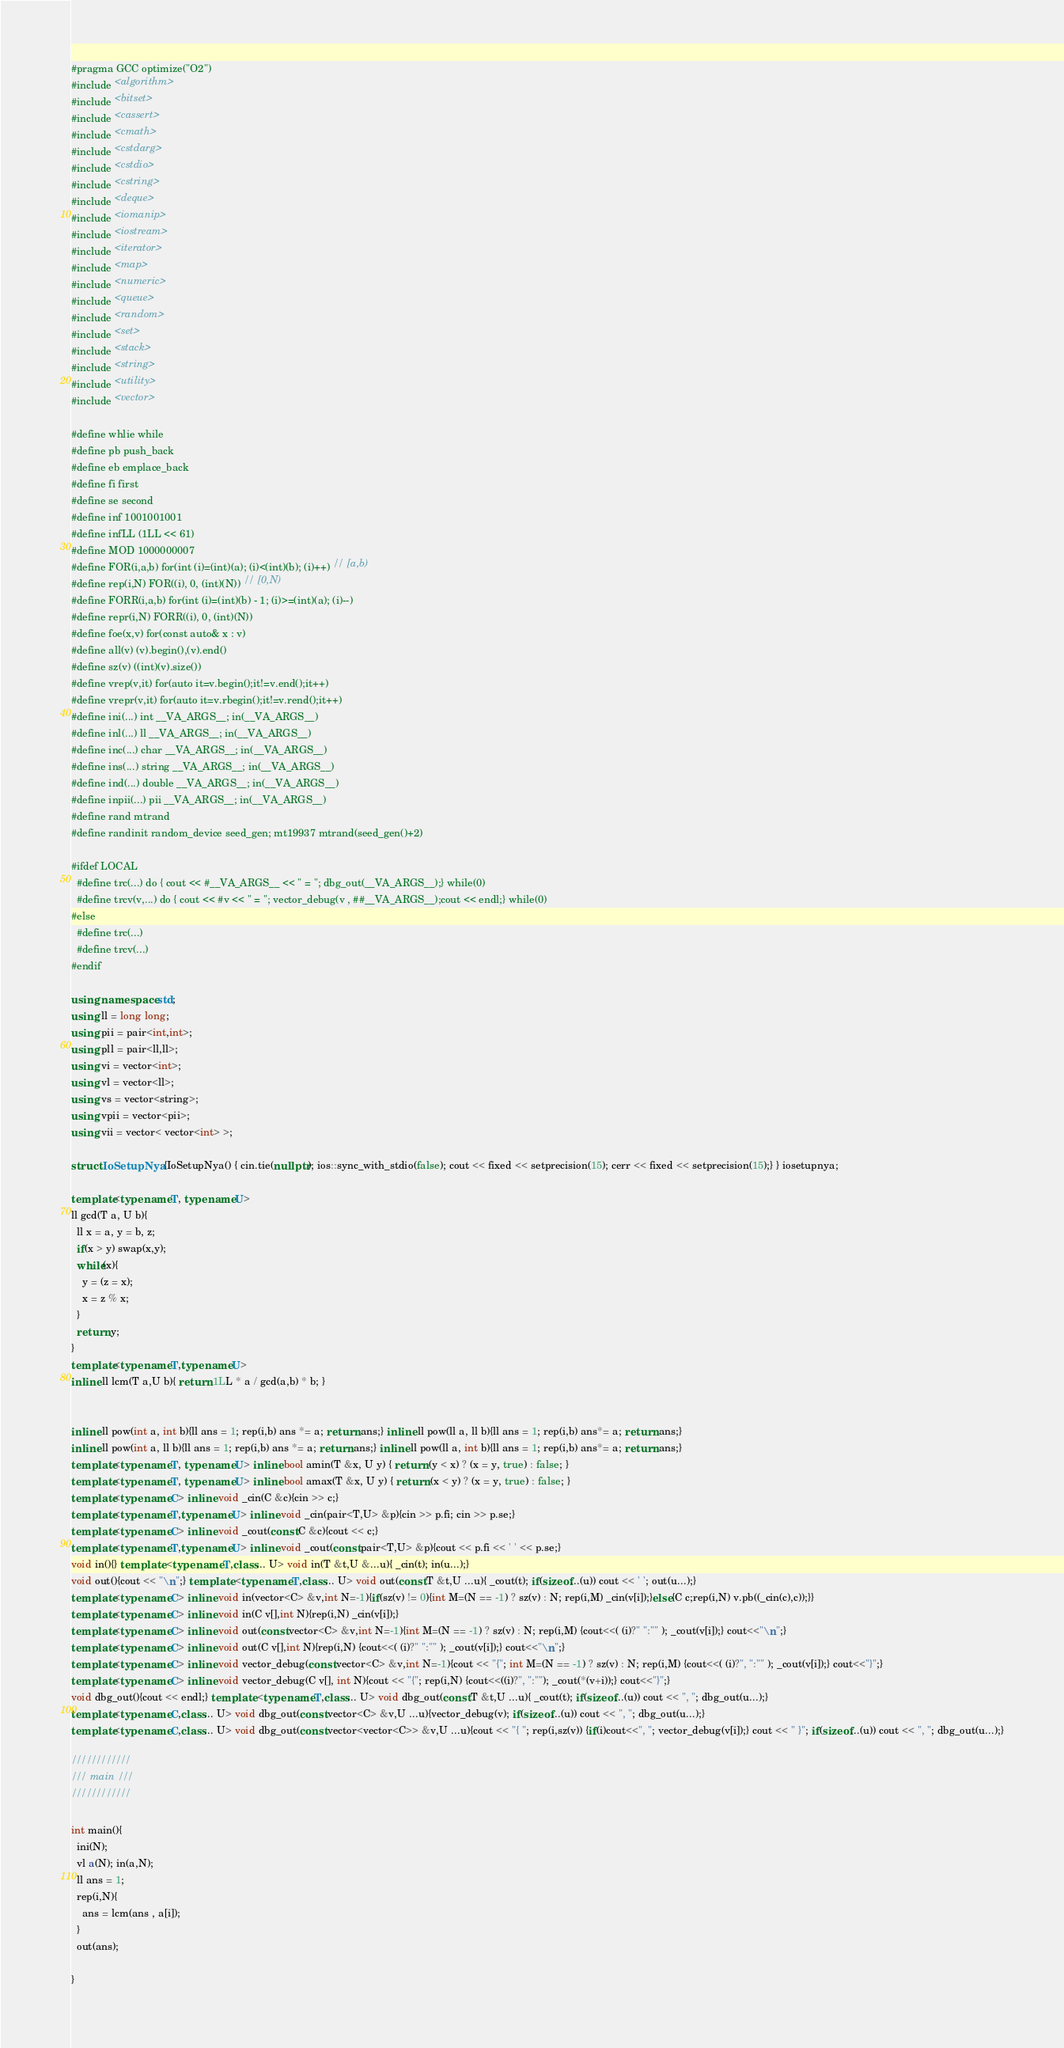<code> <loc_0><loc_0><loc_500><loc_500><_C++_>#pragma GCC optimize("O2")
#include <algorithm>
#include <bitset>
#include <cassert>
#include <cmath>
#include <cstdarg>
#include <cstdio>
#include <cstring>
#include <deque>
#include <iomanip>
#include <iostream>
#include <iterator>
#include <map>
#include <numeric>
#include <queue>
#include <random>
#include <set>
#include <stack>
#include <string>
#include <utility>
#include <vector>

#define whlie while
#define pb push_back
#define eb emplace_back
#define fi first
#define se second
#define inf 1001001001
#define infLL (1LL << 61)
#define MOD 1000000007
#define FOR(i,a,b) for(int (i)=(int)(a); (i)<(int)(b); (i)++) // [a,b)
#define rep(i,N) FOR((i), 0, (int)(N)) // [0,N)
#define FORR(i,a,b) for(int (i)=(int)(b) - 1; (i)>=(int)(a); (i)--)
#define repr(i,N) FORR((i), 0, (int)(N))
#define foe(x,v) for(const auto& x : v)
#define all(v) (v).begin(),(v).end()
#define sz(v) ((int)(v).size())
#define vrep(v,it) for(auto it=v.begin();it!=v.end();it++)
#define vrepr(v,it) for(auto it=v.rbegin();it!=v.rend();it++)
#define ini(...) int __VA_ARGS__; in(__VA_ARGS__)
#define inl(...) ll __VA_ARGS__; in(__VA_ARGS__)
#define inc(...) char __VA_ARGS__; in(__VA_ARGS__)
#define ins(...) string __VA_ARGS__; in(__VA_ARGS__)
#define ind(...) double __VA_ARGS__; in(__VA_ARGS__)
#define inpii(...) pii __VA_ARGS__; in(__VA_ARGS__)
#define rand mtrand
#define randinit random_device seed_gen; mt19937 mtrand(seed_gen()+2)

#ifdef LOCAL  
  #define trc(...) do { cout << #__VA_ARGS__ << " = "; dbg_out(__VA_ARGS__);} while(0)
  #define trcv(v,...) do { cout << #v << " = "; vector_debug(v , ##__VA_ARGS__);cout << endl;} while(0)
#else
  #define trc(...)
  #define trcv(...)
#endif

using namespace std;
using ll = long long;
using pii = pair<int,int>;
using pll = pair<ll,ll>;
using vi = vector<int>;
using vl = vector<ll>;
using vs = vector<string>;
using vpii = vector<pii>;
using vii = vector< vector<int> >;

struct IoSetupNya {IoSetupNya() { cin.tie(nullptr); ios::sync_with_stdio(false); cout << fixed << setprecision(15); cerr << fixed << setprecision(15);} } iosetupnya;

template<typename T, typename U>
ll gcd(T a, U b){
  ll x = a, y = b, z;
  if(x > y) swap(x,y);
  while(x){
    y = (z = x);
    x = z % x;
  }    
  return y;
}
template<typename T,typename U>
inline ll lcm(T a,U b){ return 1LL * a / gcd(a,b) * b; }


inline ll pow(int a, int b){ll ans = 1; rep(i,b) ans *= a; return ans;} inline ll pow(ll a, ll b){ll ans = 1; rep(i,b) ans*= a; return ans;}
inline ll pow(int a, ll b){ll ans = 1; rep(i,b) ans *= a; return ans;} inline ll pow(ll a, int b){ll ans = 1; rep(i,b) ans*= a; return ans;}
template<typename T, typename U> inline bool amin(T &x, U y) { return (y < x) ? (x = y, true) : false; }
template<typename T, typename U> inline bool amax(T &x, U y) { return (x < y) ? (x = y, true) : false; }
template<typename C> inline void _cin(C &c){cin >> c;}
template<typename T,typename U> inline void _cin(pair<T,U> &p){cin >> p.fi; cin >> p.se;}
template<typename C> inline void _cout(const C &c){cout << c;}
template<typename T,typename U> inline void _cout(const pair<T,U> &p){cout << p.fi << ' ' << p.se;}
void in(){} template <typename T,class... U> void in(T &t,U &...u){ _cin(t); in(u...);}
void out(){cout << "\n";} template <typename T,class... U> void out(const T &t,U ...u){ _cout(t); if(sizeof...(u)) cout << ' '; out(u...);}
template<typename C> inline void in(vector<C> &v,int N=-1){if(sz(v) != 0){int M=(N == -1) ? sz(v) : N; rep(i,M) _cin(v[i]);}else{C c;rep(i,N) v.pb((_cin(c),c));}}
template<typename C> inline void in(C v[],int N){rep(i,N) _cin(v[i]);}
template<typename C> inline void out(const vector<C> &v,int N=-1){int M=(N == -1) ? sz(v) : N; rep(i,M) {cout<<( (i)?" ":"" ); _cout(v[i]);} cout<<"\n";}
template<typename C> inline void out(C v[],int N){rep(i,N) {cout<<( (i)?" ":"" ); _cout(v[i]);} cout<<"\n";}
template<typename C> inline void vector_debug(const vector<C> &v,int N=-1){cout << "{"; int M=(N == -1) ? sz(v) : N; rep(i,M) {cout<<( (i)?", ":"" ); _cout(v[i]);} cout<<"}";}
template<typename C> inline void vector_debug(C v[], int N){cout << "{"; rep(i,N) {cout<<((i)?", ":""); _cout(*(v+i));} cout<<"}";}
void dbg_out(){cout << endl;} template <typename T,class... U> void dbg_out(const T &t,U ...u){ _cout(t); if(sizeof...(u)) cout << ", "; dbg_out(u...);}
template<typename C,class... U> void dbg_out(const vector<C> &v,U ...u){vector_debug(v); if(sizeof...(u)) cout << ", "; dbg_out(u...);}
template<typename C,class... U> void dbg_out(const vector<vector<C>> &v,U ...u){cout << "{ "; rep(i,sz(v)) {if(i)cout<<", "; vector_debug(v[i]);} cout << " }"; if(sizeof...(u)) cout << ", "; dbg_out(u...);}

////////////
/// main ///
////////////

int main(){
  ini(N);
  vl a(N); in(a,N);
  ll ans = 1;
  rep(i,N){
    ans = lcm(ans , a[i]);
  }
  out(ans);

}</code> 